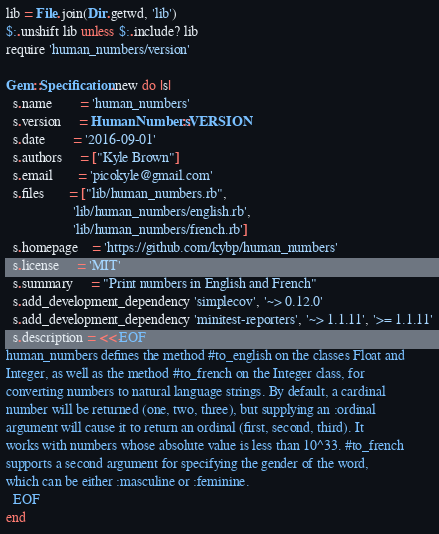Convert code to text. <code><loc_0><loc_0><loc_500><loc_500><_Ruby_>lib = File.join(Dir.getwd, 'lib')
$:.unshift lib unless $:.include? lib
require 'human_numbers/version'

Gem::Specification.new do |s|
  s.name        = 'human_numbers'
  s.version     = HumanNumbers::VERSION
  s.date        = '2016-09-01'
  s.authors     = ["Kyle Brown"]
  s.email       = 'picokyle@gmail.com'
  s.files       = ["lib/human_numbers.rb",
                   'lib/human_numbers/english.rb',
                   'lib/human_numbers/french.rb']
  s.homepage    = 'https://github.com/kybp/human_numbers'
  s.license     = 'MIT'
  s.summary     = "Print numbers in English and French"
  s.add_development_dependency 'simplecov', '~> 0.12.0'
  s.add_development_dependency 'minitest-reporters', '~> 1.1.11', '>= 1.1.11'
  s.description = <<-EOF
human_numbers defines the method #to_english on the classes Float and
Integer, as well as the method #to_french on the Integer class, for
converting numbers to natural language strings. By default, a cardinal
number will be returned (one, two, three), but supplying an :ordinal
argument will cause it to return an ordinal (first, second, third). It
works with numbers whose absolute value is less than 10^33. #to_french
supports a second argument for specifying the gender of the word,
which can be either :masculine or :feminine.
  EOF
end
</code> 